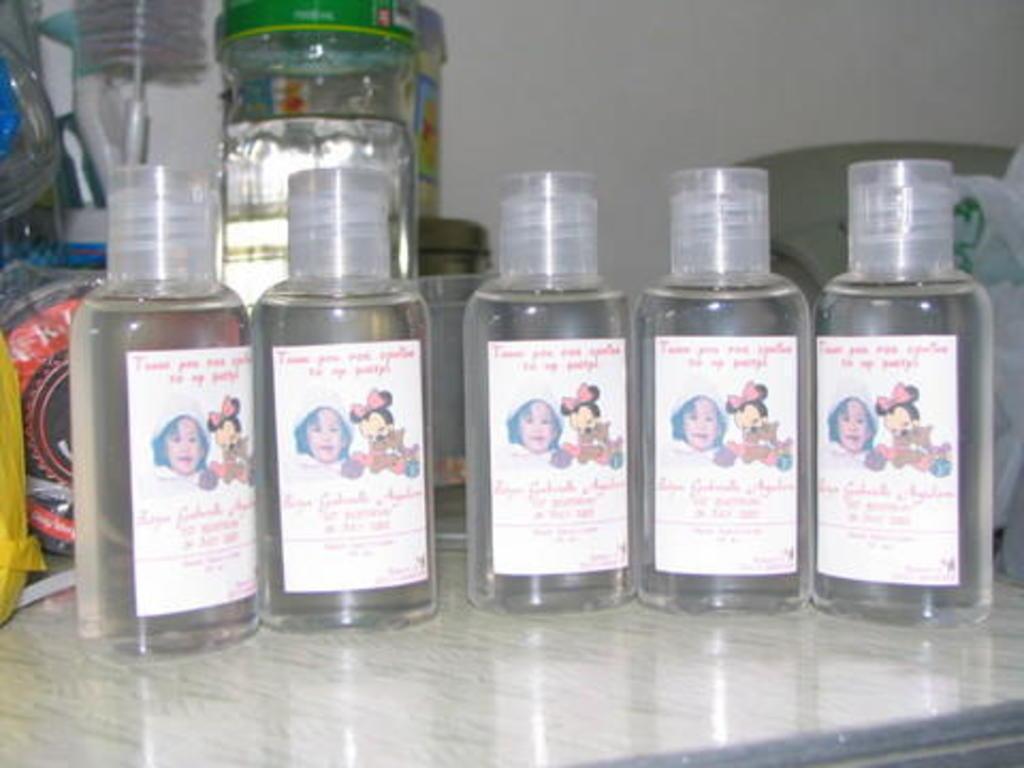Describe this image in one or two sentences. In this picture we can see bottles with stickers sticked to it and in background we can see jar, some plastic cover, wall and this bottles are placed on a glass floor. 